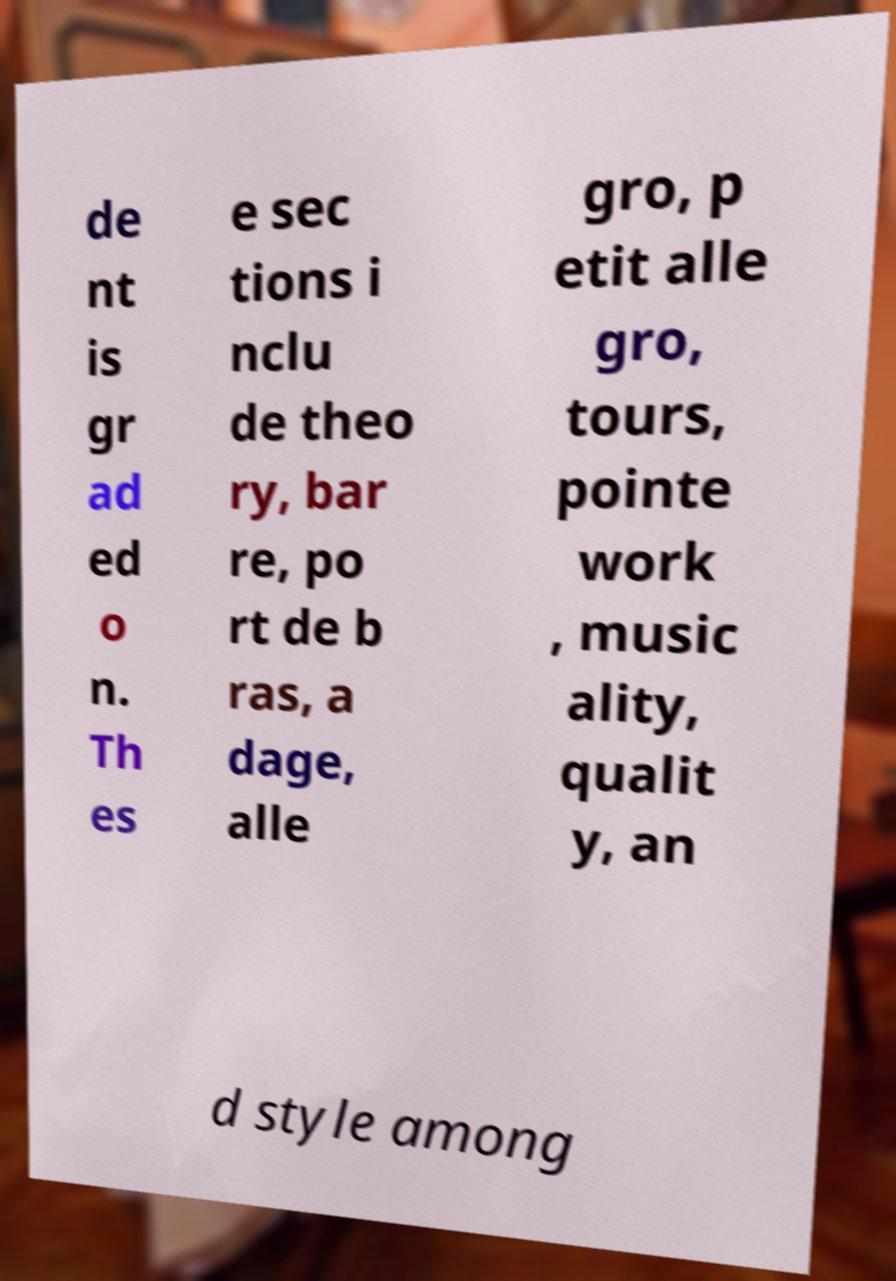Could you assist in decoding the text presented in this image and type it out clearly? de nt is gr ad ed o n. Th es e sec tions i nclu de theo ry, bar re, po rt de b ras, a dage, alle gro, p etit alle gro, tours, pointe work , music ality, qualit y, an d style among 